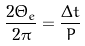<formula> <loc_0><loc_0><loc_500><loc_500>\frac { 2 \Theta _ { e } } { 2 \pi } = \frac { \Delta t } { P }</formula> 